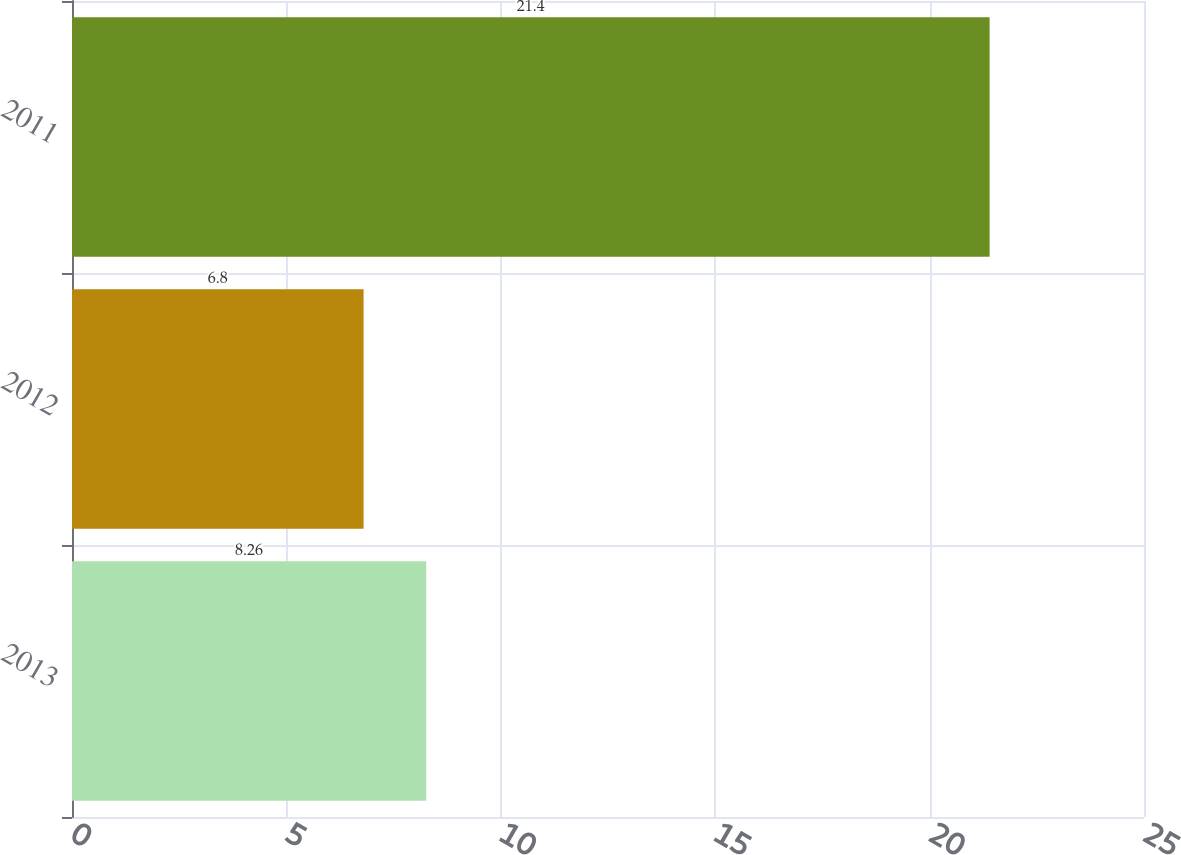Convert chart. <chart><loc_0><loc_0><loc_500><loc_500><bar_chart><fcel>2013<fcel>2012<fcel>2011<nl><fcel>8.26<fcel>6.8<fcel>21.4<nl></chart> 